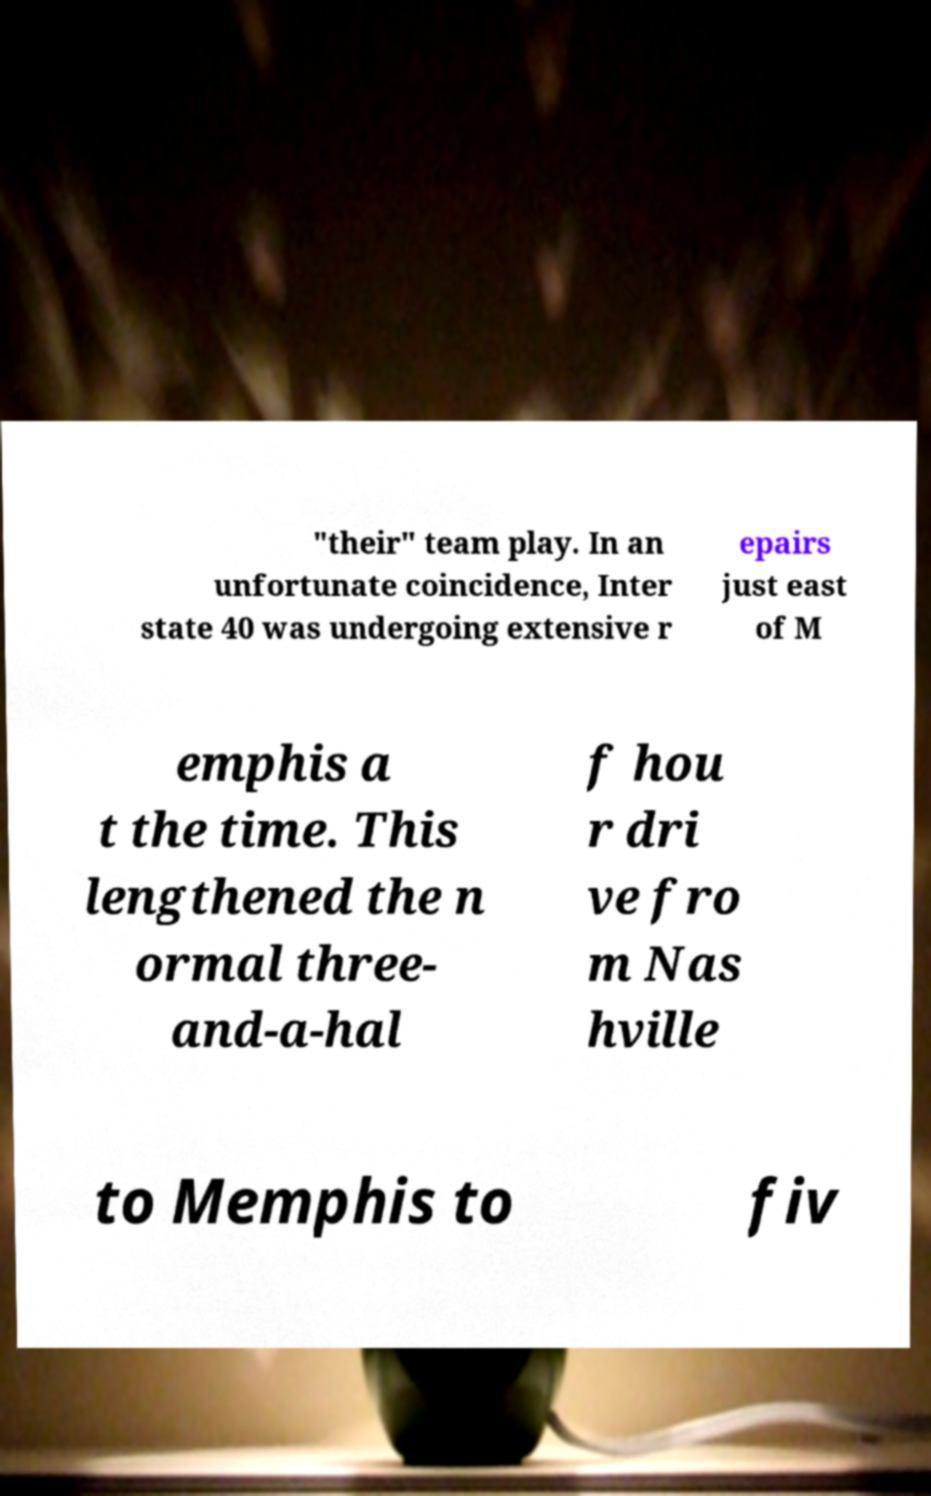Can you read and provide the text displayed in the image?This photo seems to have some interesting text. Can you extract and type it out for me? "their" team play. In an unfortunate coincidence, Inter state 40 was undergoing extensive r epairs just east of M emphis a t the time. This lengthened the n ormal three- and-a-hal f hou r dri ve fro m Nas hville to Memphis to fiv 